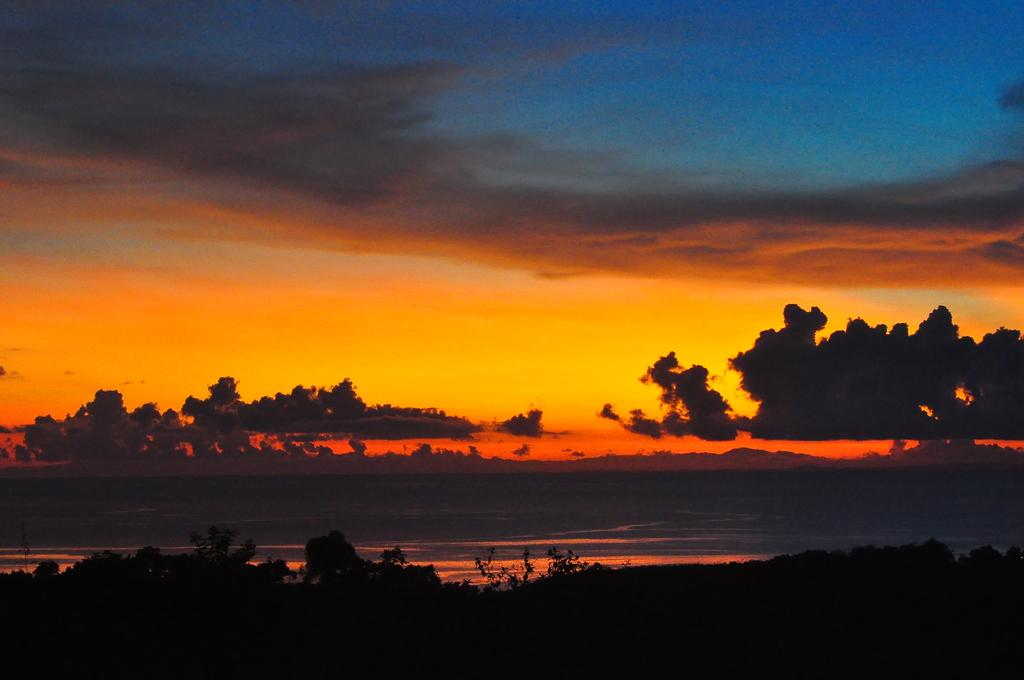What is the main element visible in the image? There is water in the image. What type of vegetation can be seen in the image? There are trees in the image. What is visible in the background of the image? The sky is visible in the background of the image. What can be observed in the sky? Clouds are present in the sky. Who is the manager of the fact in the image? There is no reference to a fact or a manager in the image, so it is not possible to answer that question. 